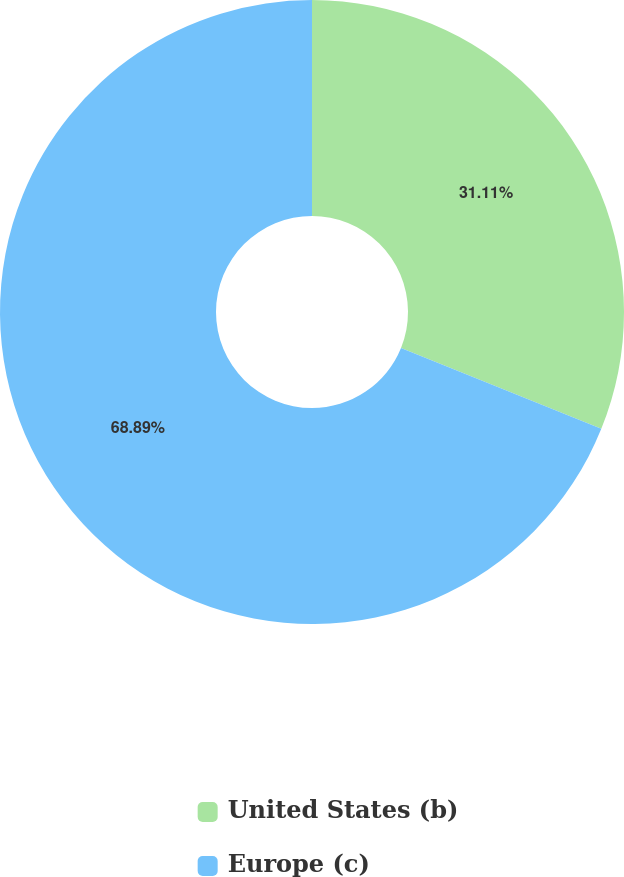Convert chart to OTSL. <chart><loc_0><loc_0><loc_500><loc_500><pie_chart><fcel>United States (b)<fcel>Europe (c)<nl><fcel>31.11%<fcel>68.89%<nl></chart> 